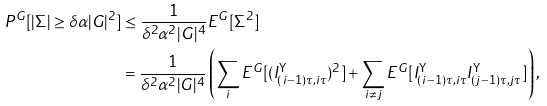Convert formula to latex. <formula><loc_0><loc_0><loc_500><loc_500>P ^ { G } [ | \Sigma | \geq \delta \alpha | G | ^ { 2 } ] & \leq \frac { 1 } { \delta ^ { 2 } \alpha ^ { 2 } | G | ^ { 4 } } E ^ { G } [ \Sigma ^ { 2 } ] \\ & = \frac { 1 } { \delta ^ { 2 } \alpha ^ { 2 } | G | ^ { 4 } } \left ( \sum _ { i } E ^ { G } [ ( I ^ { \mathsf Y } _ { ( i - 1 ) \tau , i \tau } ) ^ { 2 } ] + \sum _ { i \neq j } E ^ { G } [ I ^ { \mathsf Y } _ { ( i - 1 ) \tau , i \tau } I ^ { \mathsf Y } _ { ( j - 1 ) \tau , j \tau } ] \right ) ,</formula> 